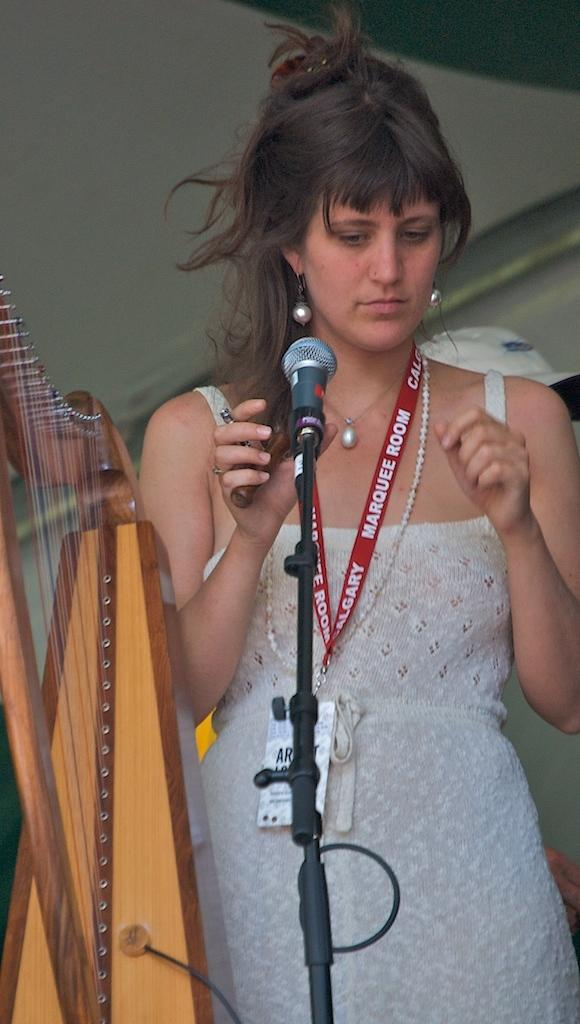What is the woman in the image doing? The woman is standing in the image. What object is in front of the woman? There is a harp in front of the woman. What equipment is set up for the woman to use? There is a microphone with a microphone stand in front of the woman. What can be seen behind the woman? There is a cap visible behind the woman. How many bikes are visible in the image? There are no bikes present in the image. What type of wave can be seen in the image? There is no wave present in the image. 